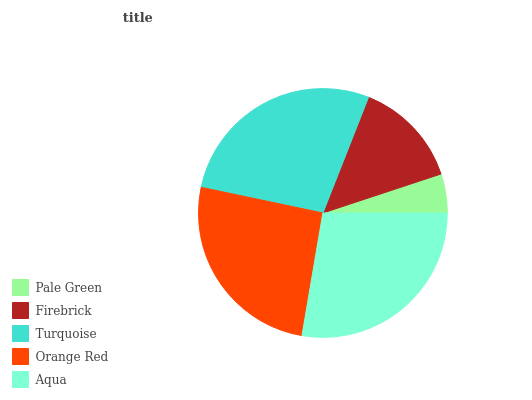Is Pale Green the minimum?
Answer yes or no. Yes. Is Aqua the maximum?
Answer yes or no. Yes. Is Firebrick the minimum?
Answer yes or no. No. Is Firebrick the maximum?
Answer yes or no. No. Is Firebrick greater than Pale Green?
Answer yes or no. Yes. Is Pale Green less than Firebrick?
Answer yes or no. Yes. Is Pale Green greater than Firebrick?
Answer yes or no. No. Is Firebrick less than Pale Green?
Answer yes or no. No. Is Orange Red the high median?
Answer yes or no. Yes. Is Orange Red the low median?
Answer yes or no. Yes. Is Firebrick the high median?
Answer yes or no. No. Is Aqua the low median?
Answer yes or no. No. 